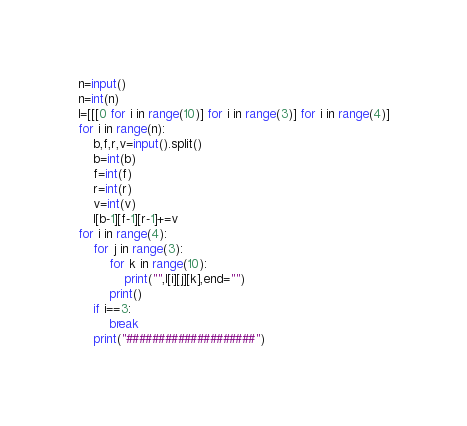Convert code to text. <code><loc_0><loc_0><loc_500><loc_500><_Python_>n=input()
n=int(n)
l=[[[0 for i in range(10)] for i in range(3)] for i in range(4)]
for i in range(n):
    b,f,r,v=input().split()
    b=int(b)
    f=int(f)
    r=int(r)
    v=int(v)
    l[b-1][f-1][r-1]+=v
for i in range(4):
    for j in range(3):
        for k in range(10):
            print("",l[i][j][k],end="")
        print()
    if i==3:
        break
    print("####################")

</code> 